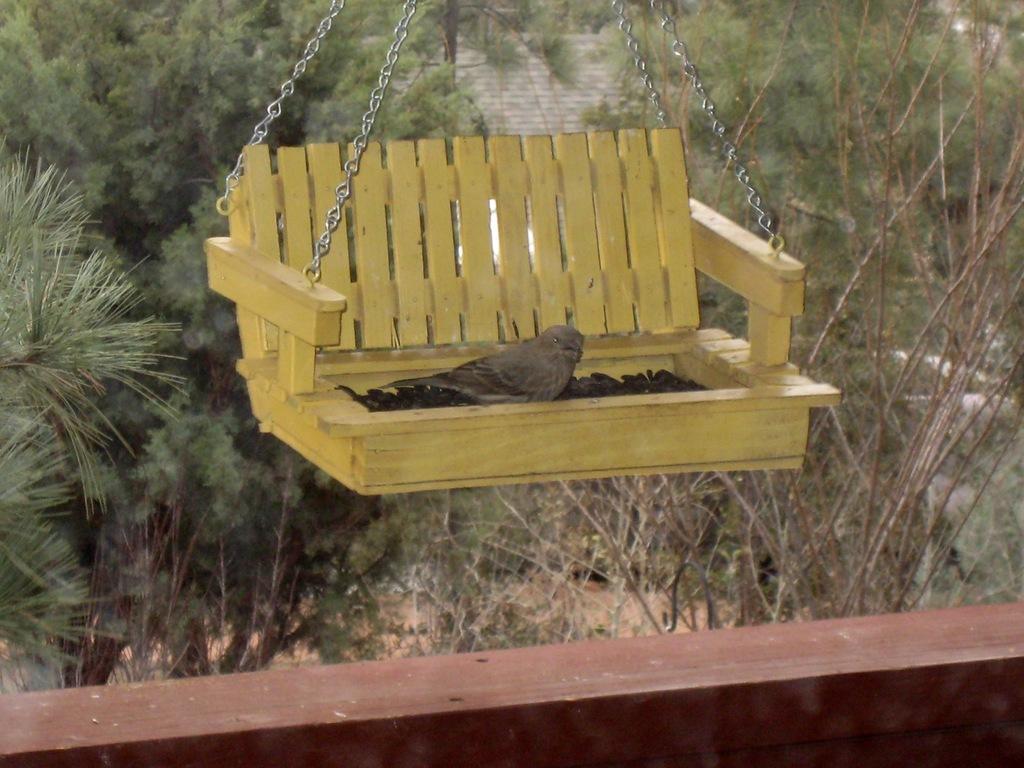In one or two sentences, can you explain what this image depicts? In the foreground of this picture, there is a bird in cradle. In the background, we can see trees, and a building roof top. 